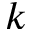Convert formula to latex. <formula><loc_0><loc_0><loc_500><loc_500>k</formula> 